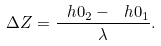<formula> <loc_0><loc_0><loc_500><loc_500>\Delta Z = \frac { \ h { 0 } _ { 2 } - \ h { 0 } _ { 1 } } { \lambda } .</formula> 